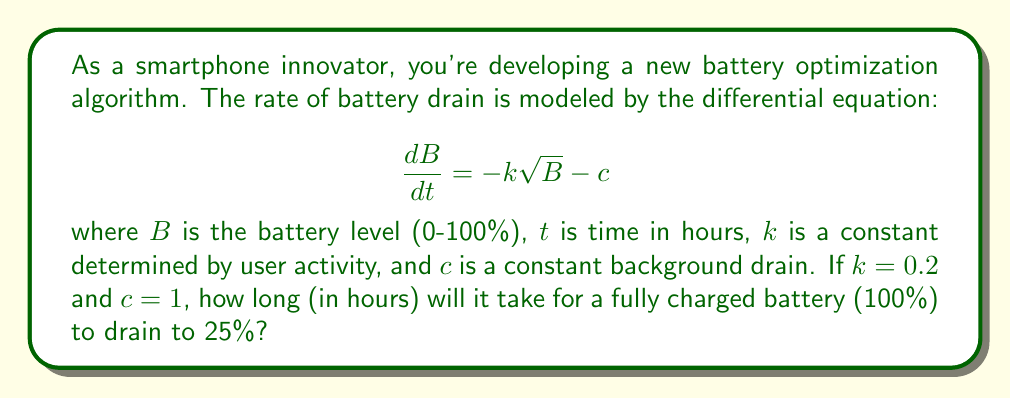Help me with this question. Let's solve this step-by-step:

1) We start with the given differential equation:
   $$\frac{dB}{dt} = -k\sqrt{B} - c$$

2) Substitute the given values $k = 0.2$ and $c = 1$:
   $$\frac{dB}{dt} = -0.2\sqrt{B} - 1$$

3) To solve this, we need to separate variables:
   $$\frac{dB}{-0.2\sqrt{B} - 1} = dt$$

4) This is a complex integral. We can solve it using the substitution $u = \sqrt{B}$:
   $$B = u^2, dB = 2u du$$
   
   The equation becomes:
   $$\frac{2u du}{-0.2u - 1} = dt$$

5) Integrating both sides:
   $$-10\ln|0.2u + 1| - 50\sqrt{B} = t + C$$

6) Now, we need to solve for the time when $B$ changes from 100% to 25%:

   At $t = 0$, $B = 100$:
   $$-10\ln|0.2\sqrt{100} + 1| - 50\sqrt{100} = 0 + C$$
   $$-10\ln(3) - 500 = C$$

   At $t = t_{final}$, $B = 25$:
   $$-10\ln|0.2\sqrt{25} + 1| - 50\sqrt{25} = t_{final} + (-10\ln(3) - 500)$$

7) Simplify and solve for $t_{final}$:
   $$-10\ln(2) - 250 = t_{final} - 10\ln(3) - 500$$
   $$t_{final} = 250 - 10\ln(2) + 10\ln(3)$$
   $$t_{final} \approx 261.03 \text{ hours}$$
Answer: 261.03 hours 